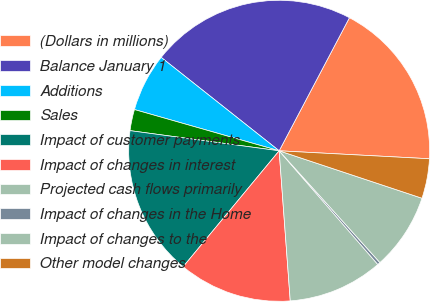Convert chart. <chart><loc_0><loc_0><loc_500><loc_500><pie_chart><fcel>(Dollars in millions)<fcel>Balance January 1<fcel>Additions<fcel>Sales<fcel>Impact of customer payments<fcel>Impact of changes in interest<fcel>Projected cash flows primarily<fcel>Impact of changes in the Home<fcel>Impact of changes to the<fcel>Other model changes<nl><fcel>18.11%<fcel>22.07%<fcel>6.24%<fcel>2.28%<fcel>16.13%<fcel>12.18%<fcel>10.2%<fcel>0.3%<fcel>8.22%<fcel>4.26%<nl></chart> 